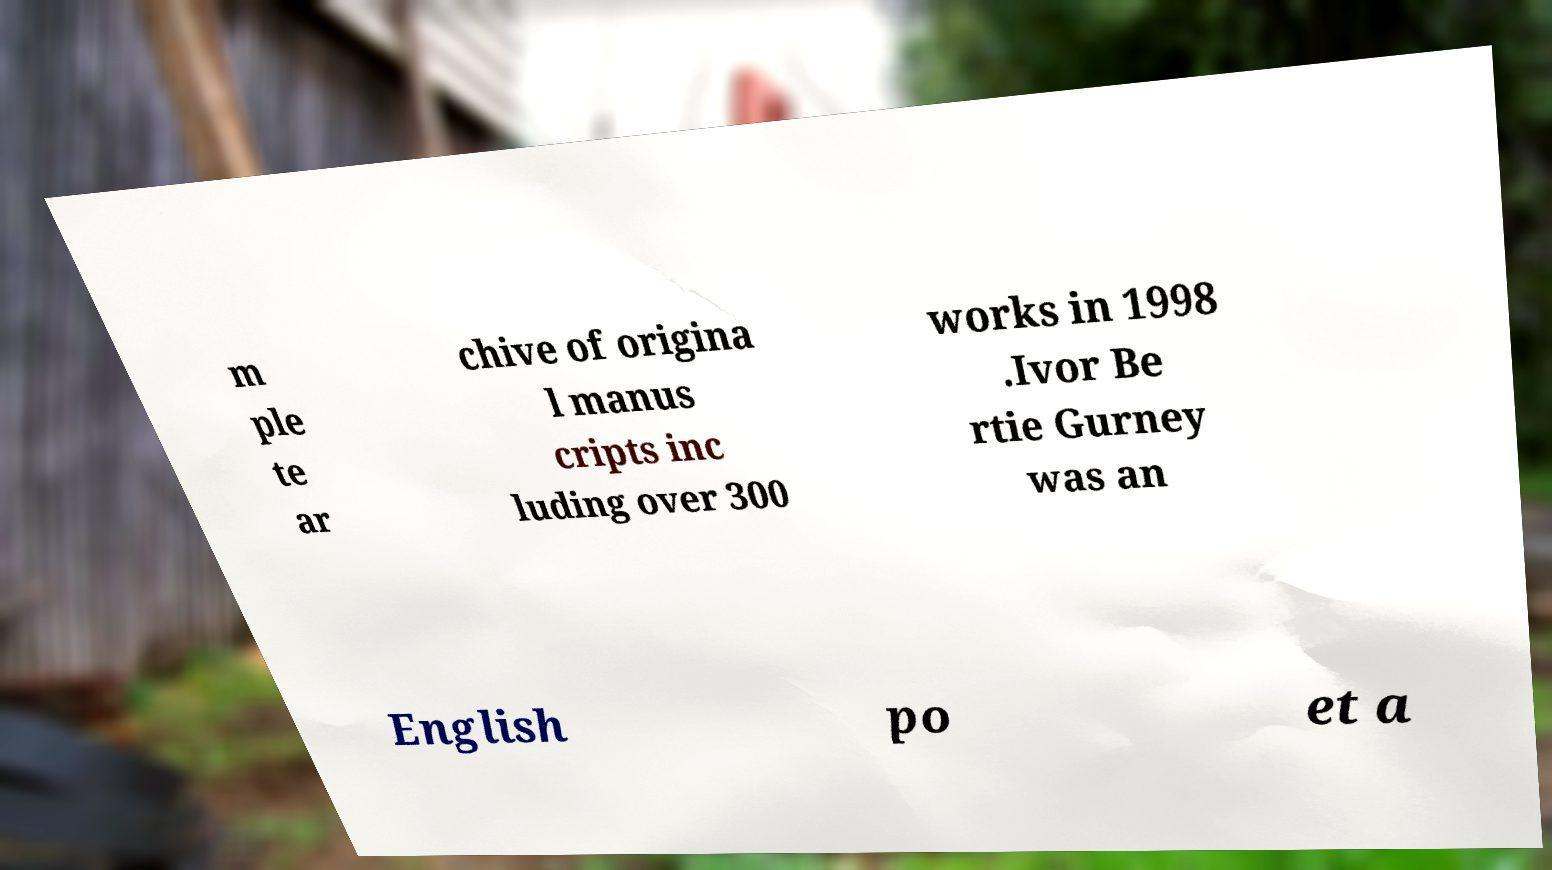For documentation purposes, I need the text within this image transcribed. Could you provide that? m ple te ar chive of origina l manus cripts inc luding over 300 works in 1998 .Ivor Be rtie Gurney was an English po et a 